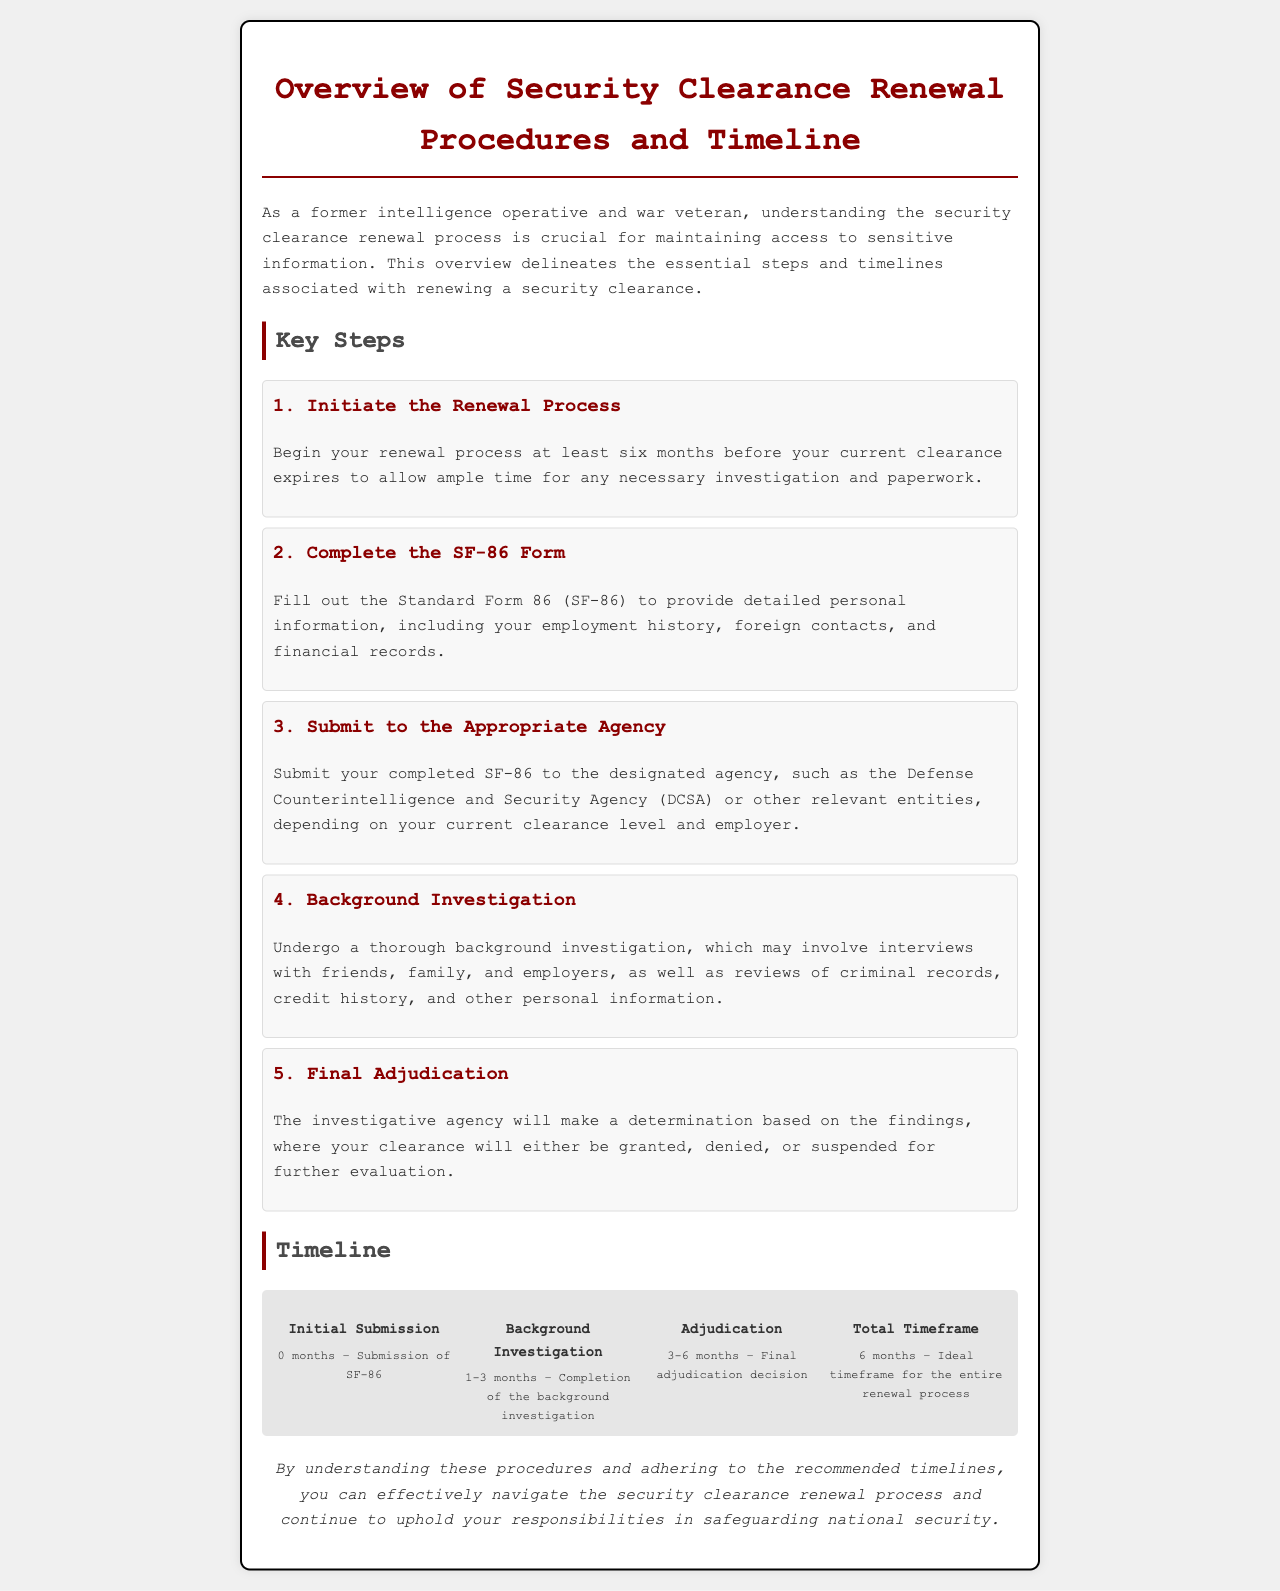What is the first step in the renewal process? The first step in the renewal process is to initiate the renewal process at least six months before your current clearance expires.
Answer: Initiate the Renewal Process How many months prior should one start the renewal process? The document states that one should start the renewal process at least six months before the expiration.
Answer: Six months What form needs to be completed? The document specifies the completion of the Standard Form 86 (SF-86).
Answer: SF-86 Which agency is mentioned for submission of the SF-86? The document mentions the Defense Counterintelligence and Security Agency (DCSA) for submission.
Answer: DCSA What is the duration for background investigation completion? The background investigation is indicated to take between 1 to 3 months.
Answer: 1-3 months What is the ideal timeframe for the entire renewal process? The document states that the ideal timeframe for the entire renewal process is six months.
Answer: Six months What happens after the background investigation? The next step after the background investigation is final adjudication.
Answer: Final Adjudication What is the determination made by the investigative agency? The determination made by the agency can be that the clearance is granted, denied, or suspended.
Answer: Granted, denied, or suspended What type of conclusion is provided at the end of the document? The conclusion provided at the end of the document is italicized and summarizes the importance of understanding the renewal procedures and timelines.
Answer: Italicized conclusion 